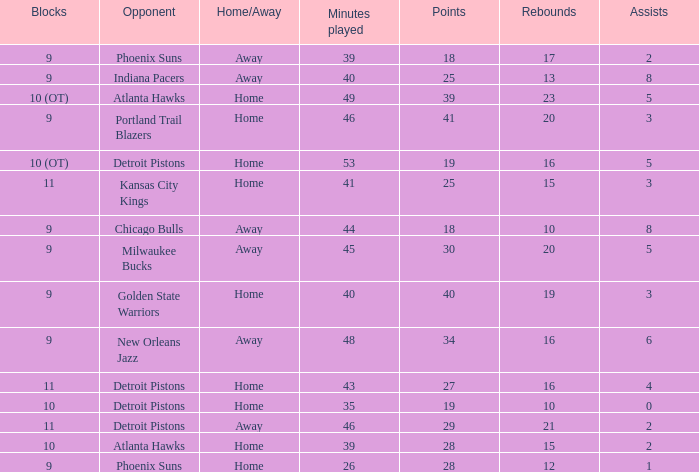When the number of rebounds was less than 16 and assists were 5, how many points were scored? 0.0. 